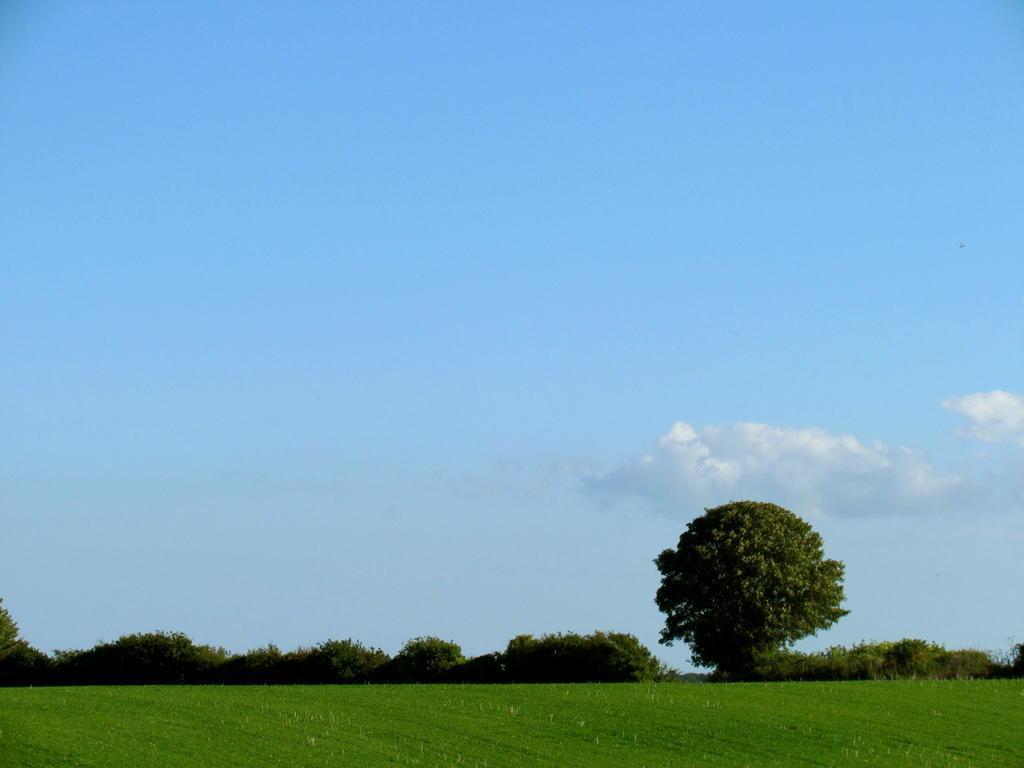In one or two sentences, can you explain what this image depicts? In this picture there is greenery at the bottom side of the image and there is sky at the top side of the image. 